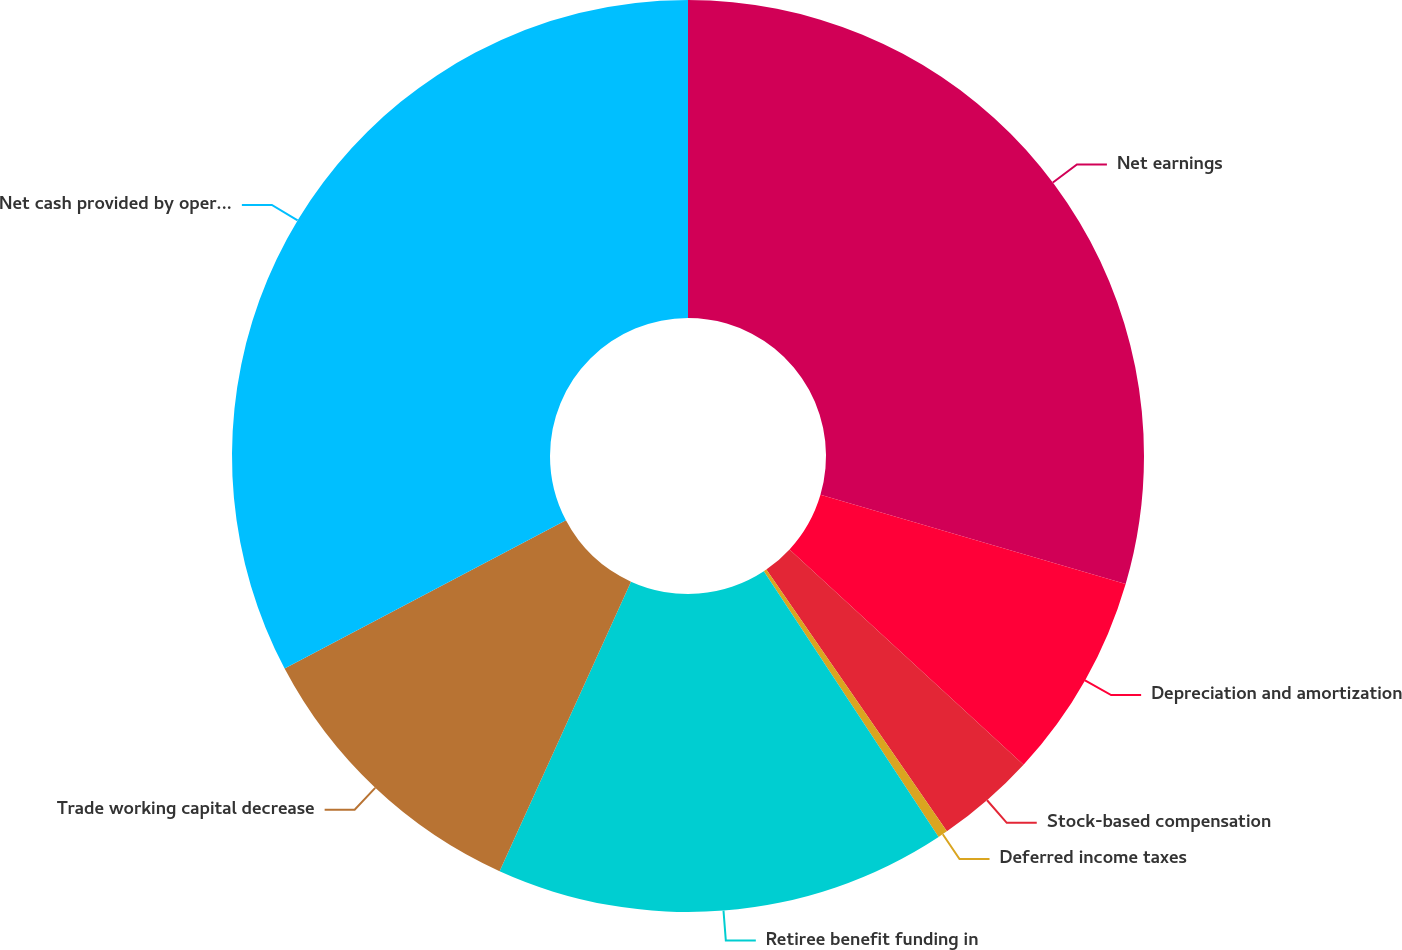<chart> <loc_0><loc_0><loc_500><loc_500><pie_chart><fcel>Net earnings<fcel>Depreciation and amortization<fcel>Stock-based compensation<fcel>Deferred income taxes<fcel>Retiree benefit funding in<fcel>Trade working capital decrease<fcel>Net cash provided by operating<nl><fcel>29.53%<fcel>7.31%<fcel>3.55%<fcel>0.35%<fcel>16.04%<fcel>10.5%<fcel>32.72%<nl></chart> 